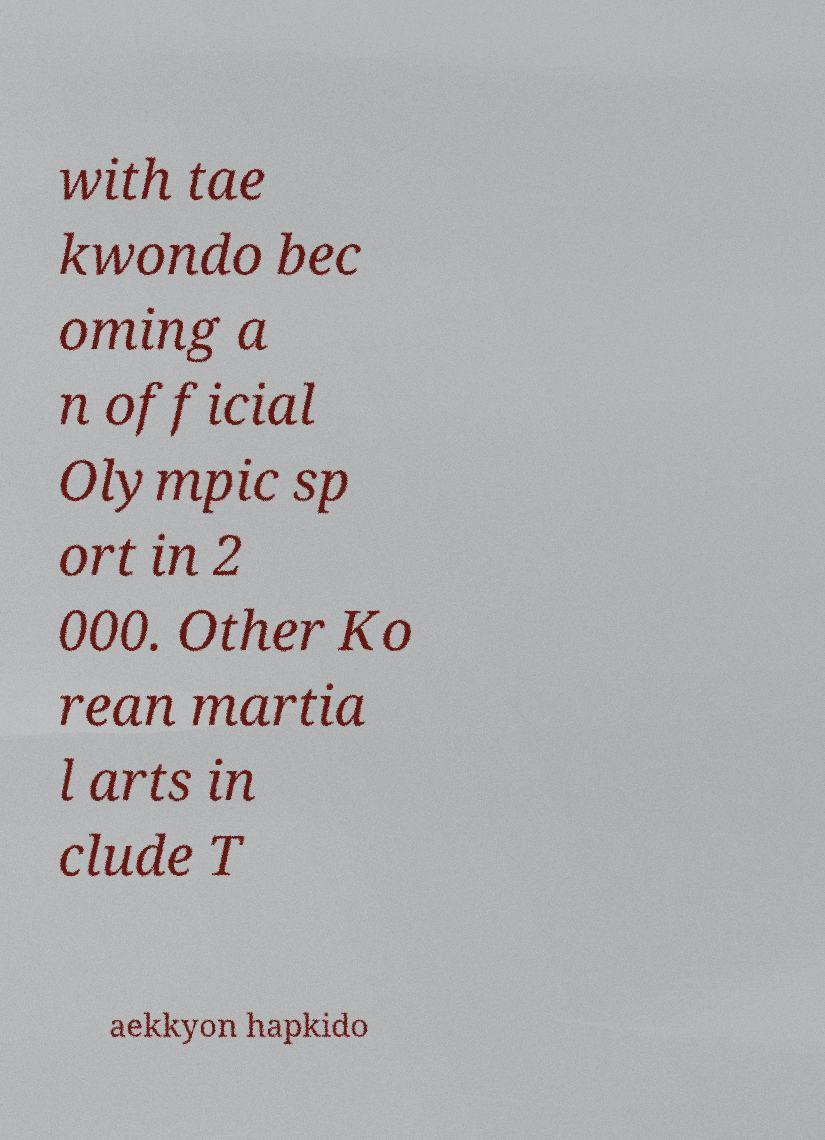Can you read and provide the text displayed in the image?This photo seems to have some interesting text. Can you extract and type it out for me? with tae kwondo bec oming a n official Olympic sp ort in 2 000. Other Ko rean martia l arts in clude T aekkyon hapkido 